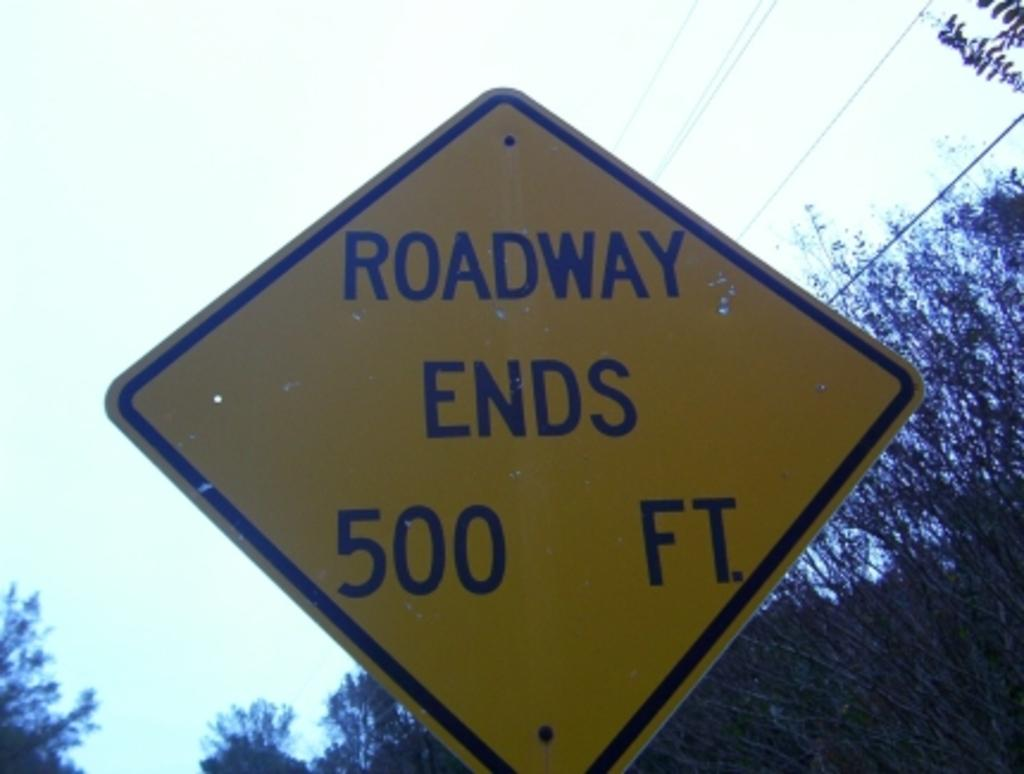What is the main object in the image? There is a sign board in the image. What can be seen on the right side of the image? There are trees on the right side of the image. What is visible in the background of the image? There is a sky visible in the background of the image. What type of drum is being played in the image? There is no drum present in the image. What historical event is depicted in the image? There is no historical event depicted in the image; it features a sign board, trees, and a sky. 